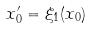Convert formula to latex. <formula><loc_0><loc_0><loc_500><loc_500>x _ { 0 } ^ { \prime } = \xi _ { 1 } ( x _ { 0 } )</formula> 